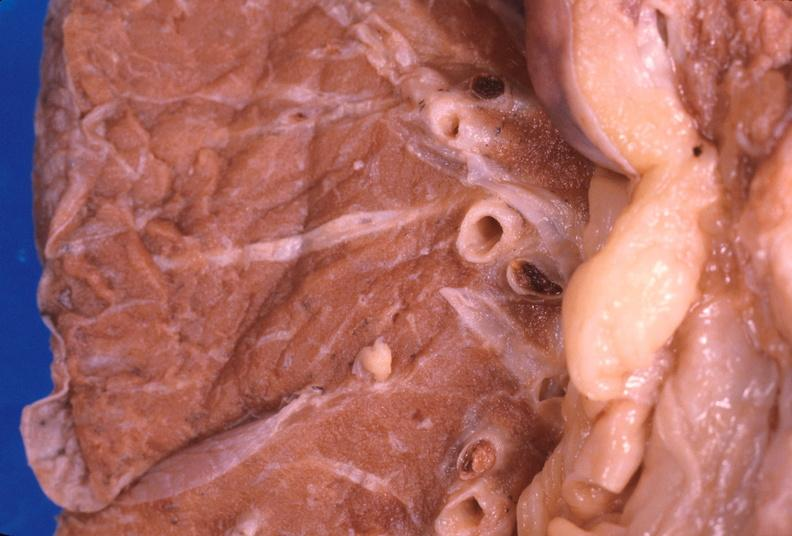s respiratory present?
Answer the question using a single word or phrase. Yes 